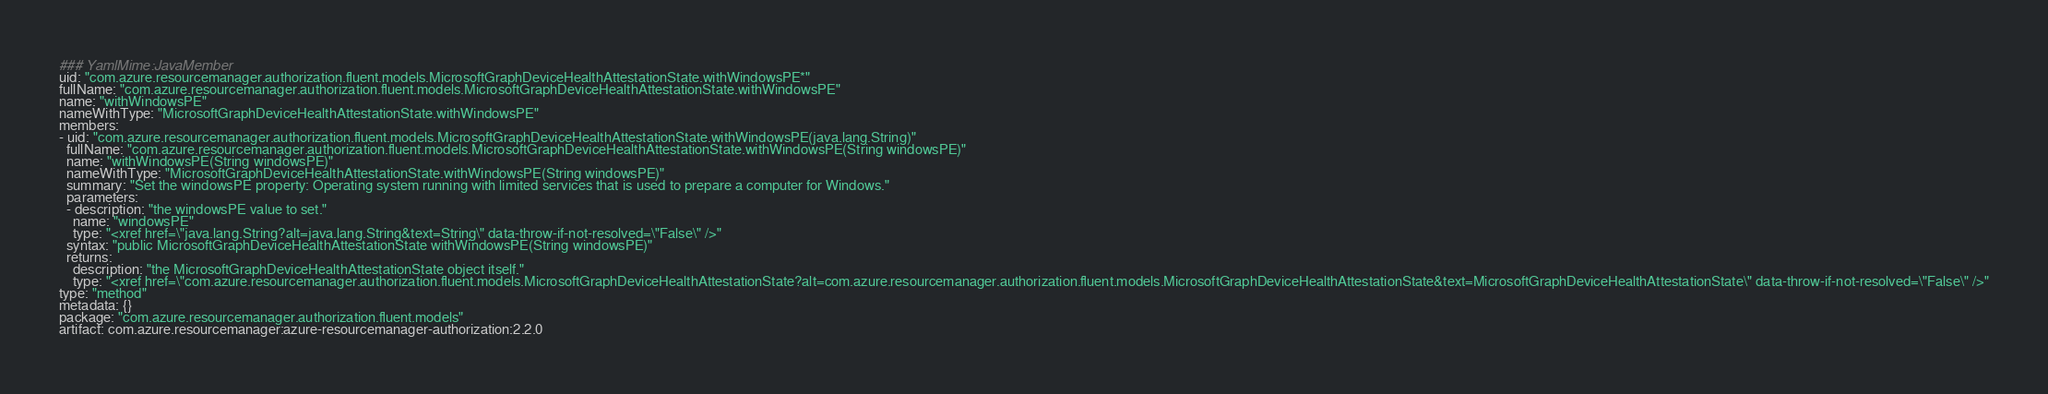Convert code to text. <code><loc_0><loc_0><loc_500><loc_500><_YAML_>### YamlMime:JavaMember
uid: "com.azure.resourcemanager.authorization.fluent.models.MicrosoftGraphDeviceHealthAttestationState.withWindowsPE*"
fullName: "com.azure.resourcemanager.authorization.fluent.models.MicrosoftGraphDeviceHealthAttestationState.withWindowsPE"
name: "withWindowsPE"
nameWithType: "MicrosoftGraphDeviceHealthAttestationState.withWindowsPE"
members:
- uid: "com.azure.resourcemanager.authorization.fluent.models.MicrosoftGraphDeviceHealthAttestationState.withWindowsPE(java.lang.String)"
  fullName: "com.azure.resourcemanager.authorization.fluent.models.MicrosoftGraphDeviceHealthAttestationState.withWindowsPE(String windowsPE)"
  name: "withWindowsPE(String windowsPE)"
  nameWithType: "MicrosoftGraphDeviceHealthAttestationState.withWindowsPE(String windowsPE)"
  summary: "Set the windowsPE property: Operating system running with limited services that is used to prepare a computer for Windows."
  parameters:
  - description: "the windowsPE value to set."
    name: "windowsPE"
    type: "<xref href=\"java.lang.String?alt=java.lang.String&text=String\" data-throw-if-not-resolved=\"False\" />"
  syntax: "public MicrosoftGraphDeviceHealthAttestationState withWindowsPE(String windowsPE)"
  returns:
    description: "the MicrosoftGraphDeviceHealthAttestationState object itself."
    type: "<xref href=\"com.azure.resourcemanager.authorization.fluent.models.MicrosoftGraphDeviceHealthAttestationState?alt=com.azure.resourcemanager.authorization.fluent.models.MicrosoftGraphDeviceHealthAttestationState&text=MicrosoftGraphDeviceHealthAttestationState\" data-throw-if-not-resolved=\"False\" />"
type: "method"
metadata: {}
package: "com.azure.resourcemanager.authorization.fluent.models"
artifact: com.azure.resourcemanager:azure-resourcemanager-authorization:2.2.0
</code> 